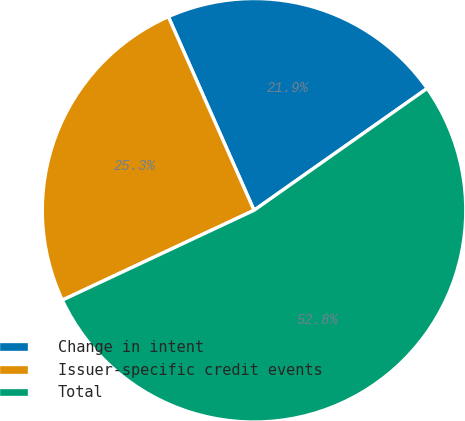Convert chart. <chart><loc_0><loc_0><loc_500><loc_500><pie_chart><fcel>Change in intent<fcel>Issuer-specific credit events<fcel>Total<nl><fcel>21.87%<fcel>25.34%<fcel>52.79%<nl></chart> 